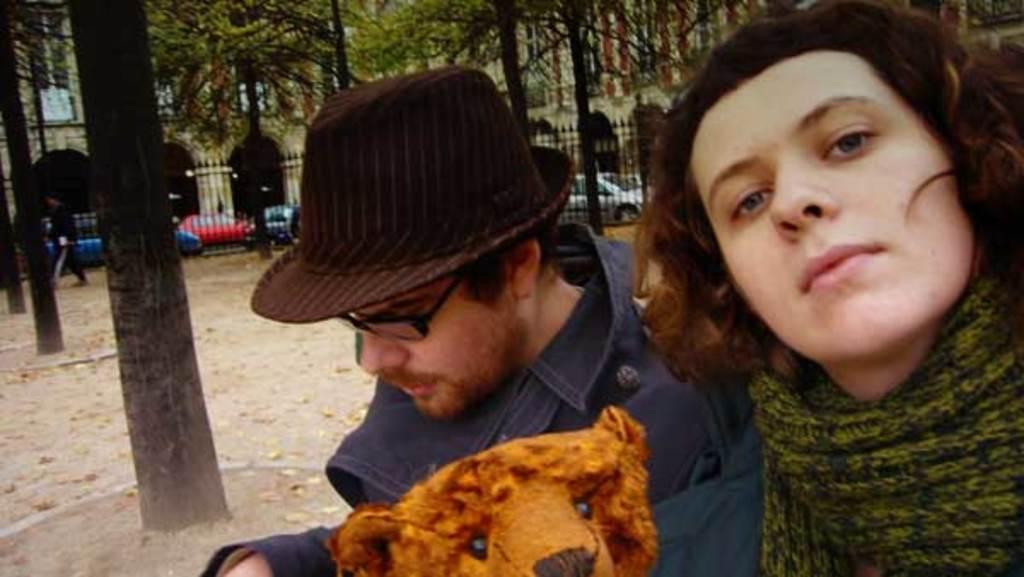How would you summarize this image in a sentence or two? This picture describes about group of people, in the middle of the image we can see a man, he wore spectacles and a cap, and he is holding a toy, in the background we can see few trees, vehicles and buildings. 